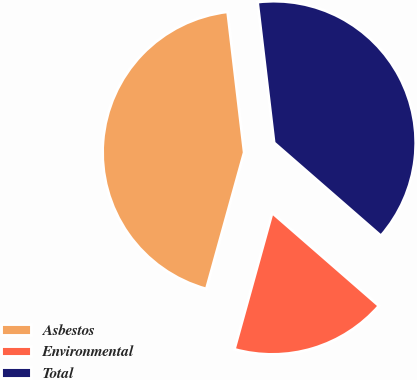Convert chart. <chart><loc_0><loc_0><loc_500><loc_500><pie_chart><fcel>Asbestos<fcel>Environmental<fcel>Total<nl><fcel>43.83%<fcel>17.9%<fcel>38.27%<nl></chart> 